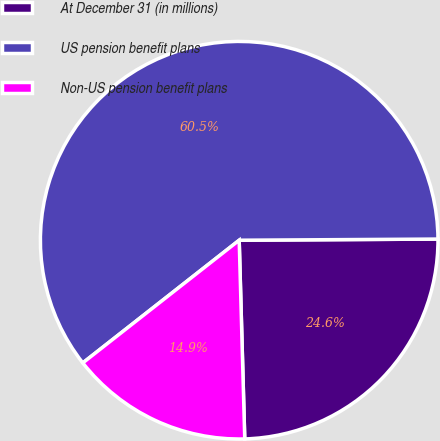Convert chart. <chart><loc_0><loc_0><loc_500><loc_500><pie_chart><fcel>At December 31 (in millions)<fcel>US pension benefit plans<fcel>Non-US pension benefit plans<nl><fcel>24.65%<fcel>60.5%<fcel>14.86%<nl></chart> 